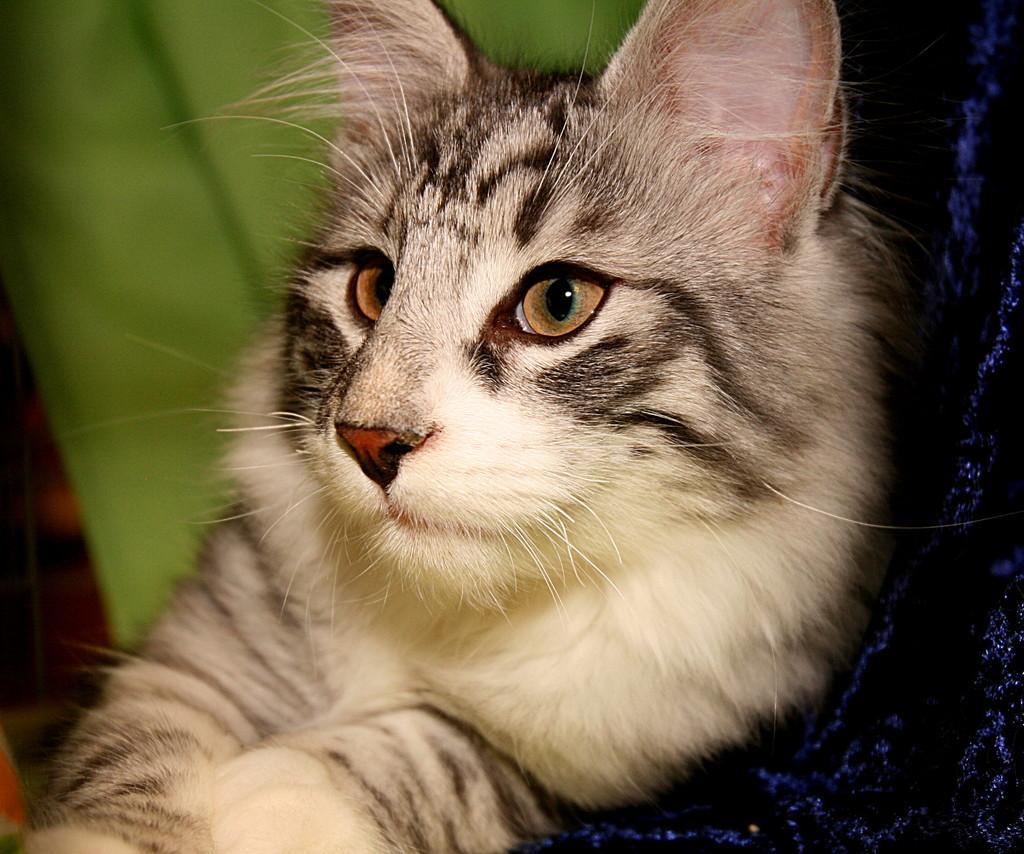How would you summarize this image in a sentence or two? In a given image I can see a cat. 